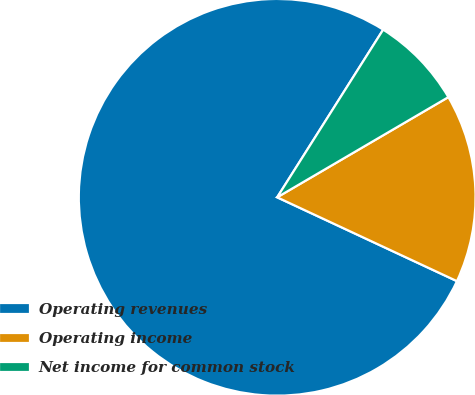<chart> <loc_0><loc_0><loc_500><loc_500><pie_chart><fcel>Operating revenues<fcel>Operating income<fcel>Net income for common stock<nl><fcel>77.02%<fcel>15.37%<fcel>7.6%<nl></chart> 